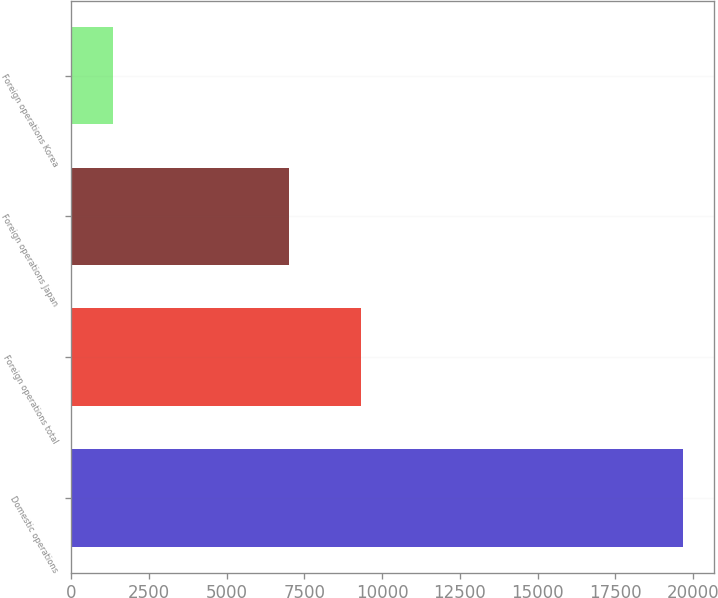Convert chart to OTSL. <chart><loc_0><loc_0><loc_500><loc_500><bar_chart><fcel>Domestic operations<fcel>Foreign operations total<fcel>Foreign operations Japan<fcel>Foreign operations Korea<nl><fcel>19674<fcel>9316<fcel>7017<fcel>1362<nl></chart> 